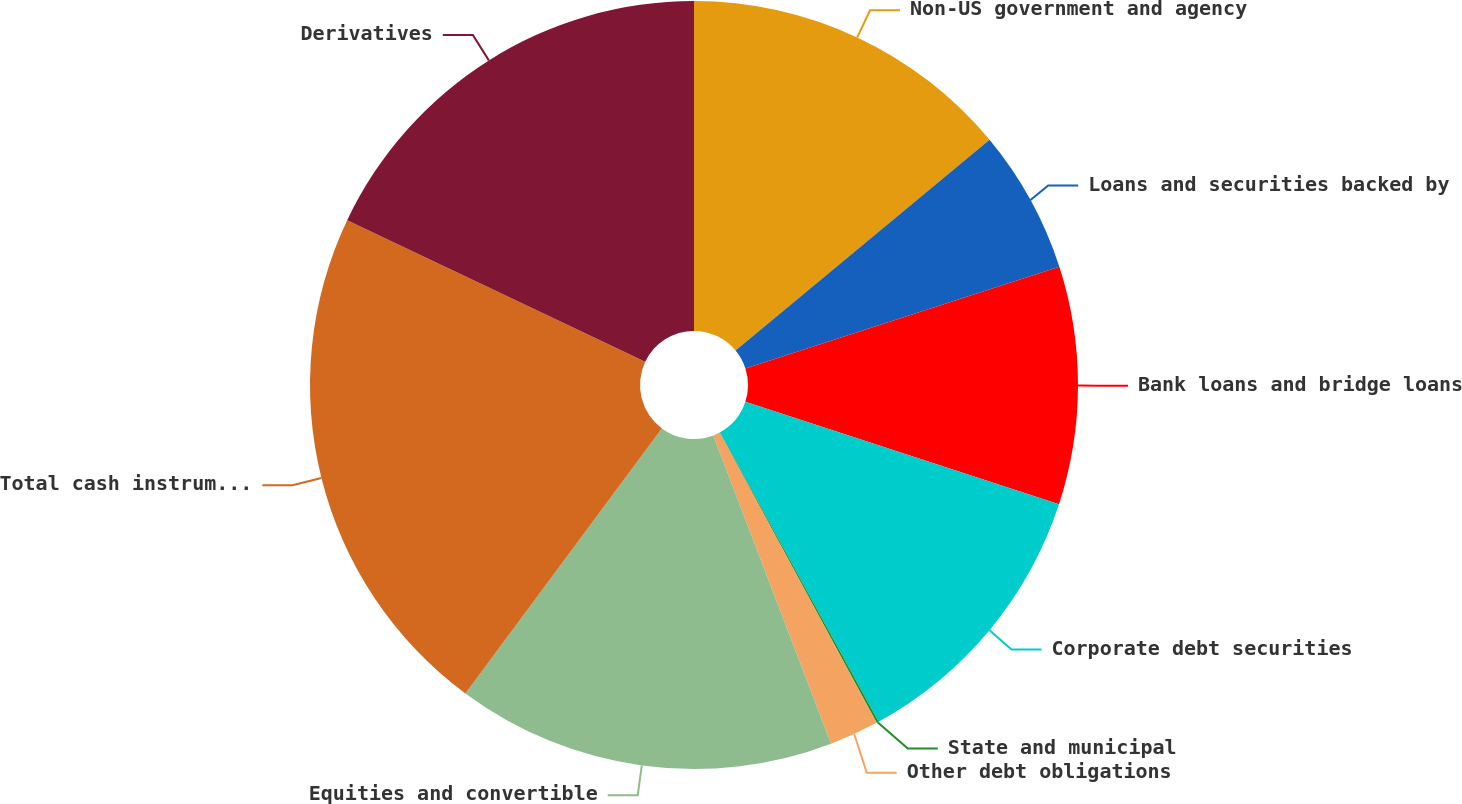Convert chart to OTSL. <chart><loc_0><loc_0><loc_500><loc_500><pie_chart><fcel>Non-US government and agency<fcel>Loans and securities backed by<fcel>Bank loans and bridge loans<fcel>Corporate debt securities<fcel>State and municipal<fcel>Other debt obligations<fcel>Equities and convertible<fcel>Total cash instruments<fcel>Derivatives<nl><fcel>13.98%<fcel>6.04%<fcel>10.01%<fcel>11.99%<fcel>0.09%<fcel>2.08%<fcel>15.96%<fcel>21.91%<fcel>17.94%<nl></chart> 